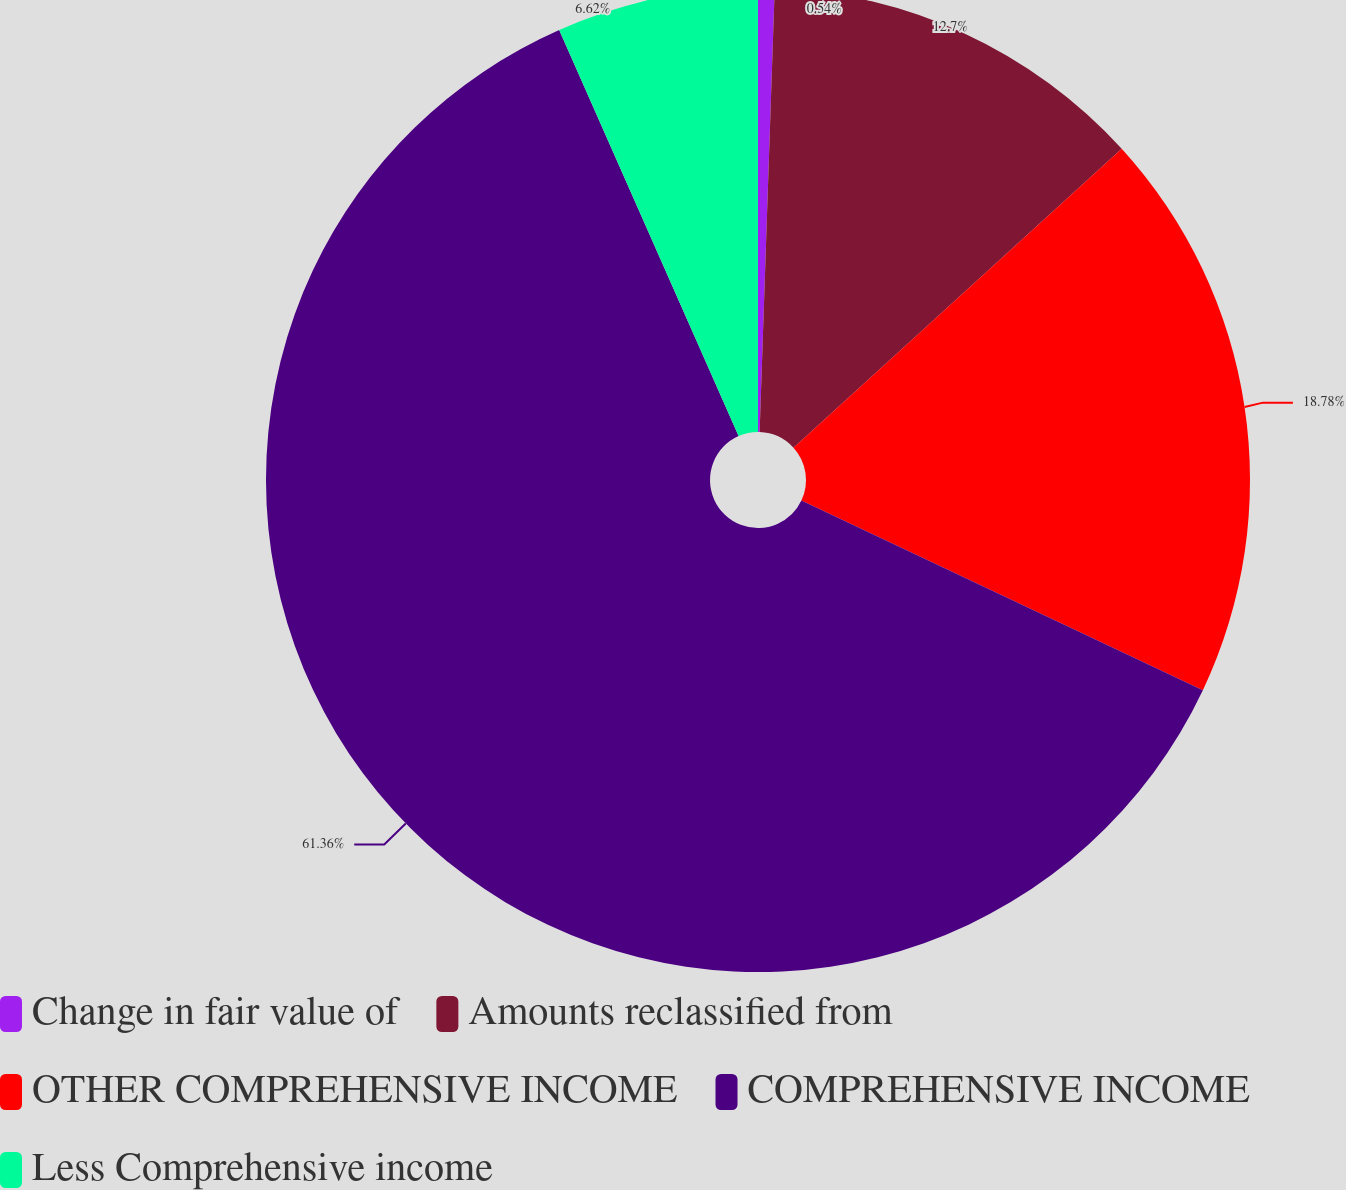Convert chart to OTSL. <chart><loc_0><loc_0><loc_500><loc_500><pie_chart><fcel>Change in fair value of<fcel>Amounts reclassified from<fcel>OTHER COMPREHENSIVE INCOME<fcel>COMPREHENSIVE INCOME<fcel>Less Comprehensive income<nl><fcel>0.54%<fcel>12.7%<fcel>18.78%<fcel>61.35%<fcel>6.62%<nl></chart> 